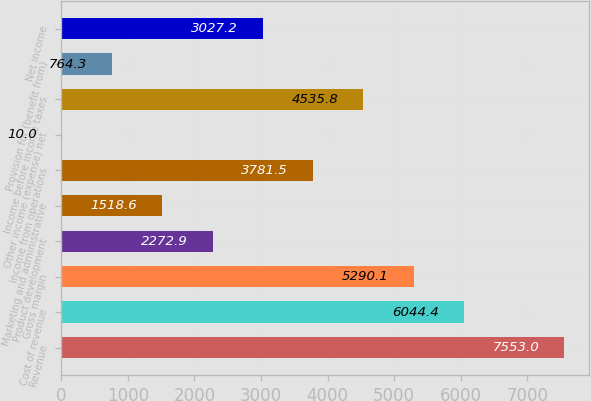Convert chart to OTSL. <chart><loc_0><loc_0><loc_500><loc_500><bar_chart><fcel>Revenue<fcel>Cost of revenue<fcel>Gross margin<fcel>Product development<fcel>Marketing and administrative<fcel>Income from operations<fcel>Other income (expense) net<fcel>Income before income taxes<fcel>Provision for (benefit from)<fcel>Net income<nl><fcel>7553<fcel>6044.4<fcel>5290.1<fcel>2272.9<fcel>1518.6<fcel>3781.5<fcel>10<fcel>4535.8<fcel>764.3<fcel>3027.2<nl></chart> 